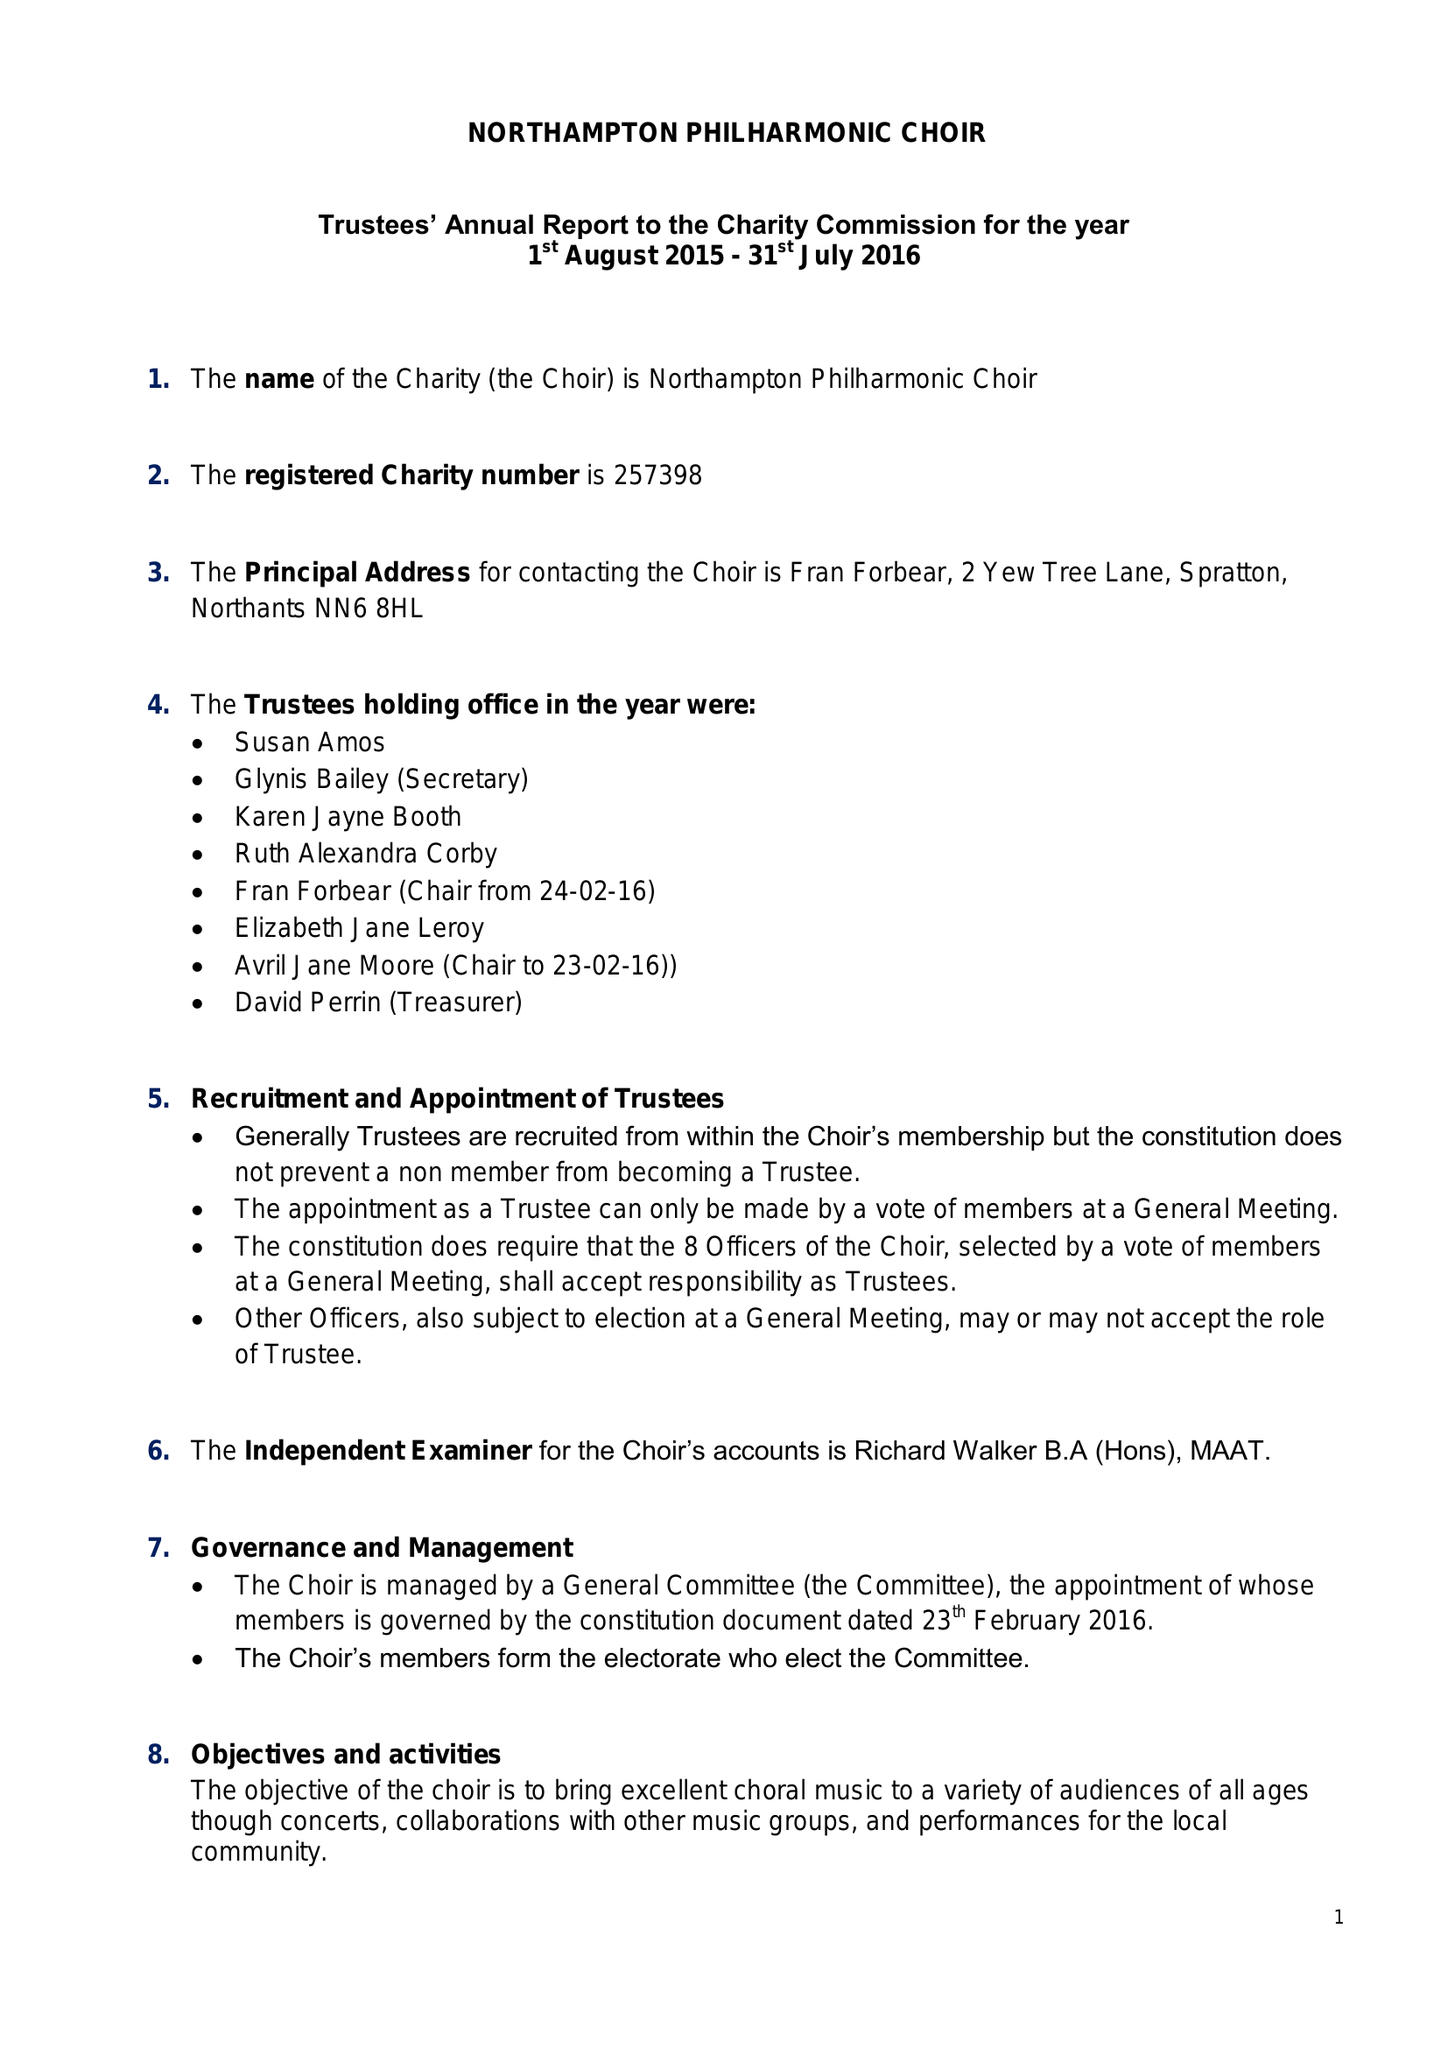What is the value for the report_date?
Answer the question using a single word or phrase. 2016-07-31 